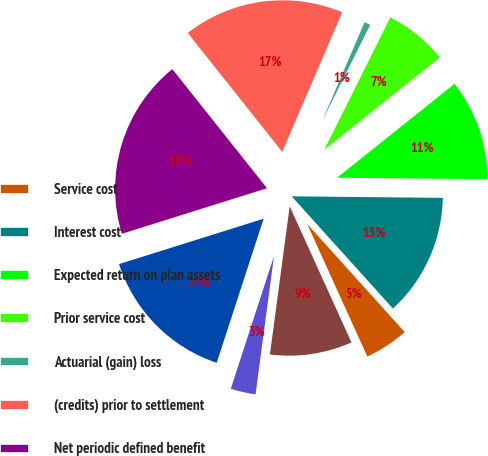Convert chart. <chart><loc_0><loc_0><loc_500><loc_500><pie_chart><fcel>Service cost<fcel>Interest cost<fcel>Expected return on plan assets<fcel>Prior service cost<fcel>Actuarial (gain) loss<fcel>(credits) prior to settlement<fcel>Net periodic defined benefit<fcel>Current year net (gain) loss<fcel>Actuarial loss<fcel>Total recognized in OCI and<nl><fcel>4.9%<fcel>13.16%<fcel>10.89%<fcel>6.9%<fcel>0.91%<fcel>17.15%<fcel>19.15%<fcel>15.15%<fcel>2.9%<fcel>8.89%<nl></chart> 